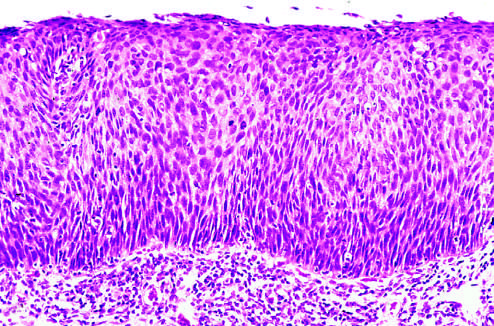what is intact?
Answer the question using a single word or phrase. The basement membrane 